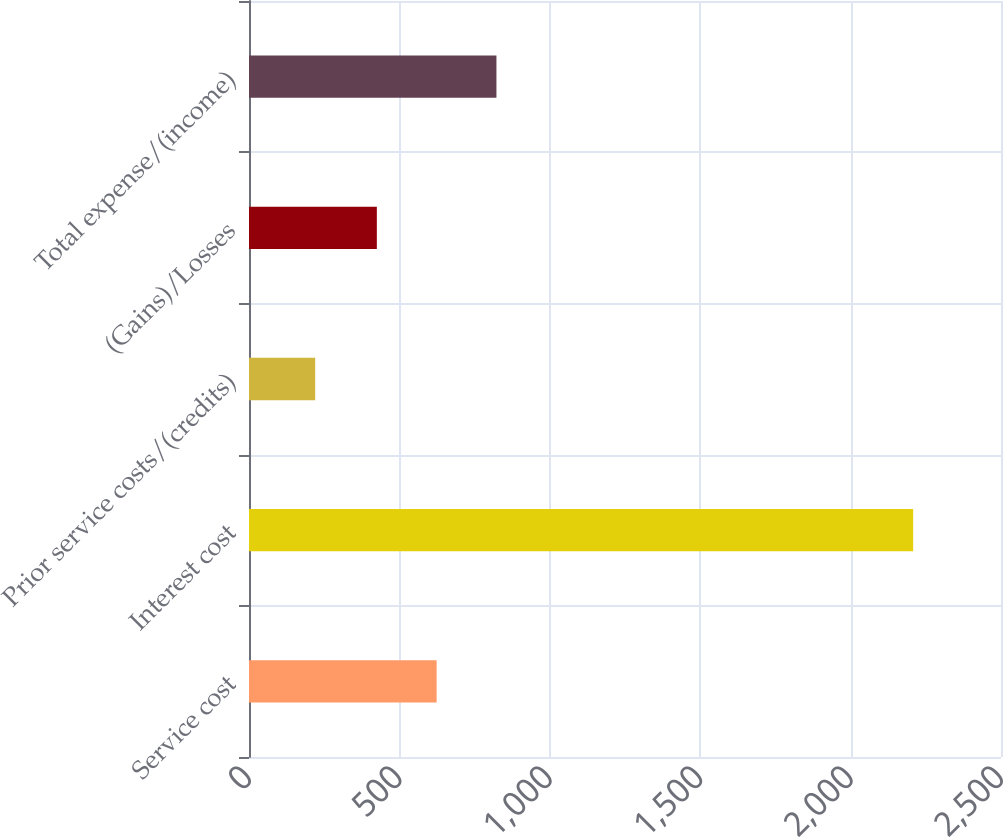Convert chart to OTSL. <chart><loc_0><loc_0><loc_500><loc_500><bar_chart><fcel>Service cost<fcel>Interest cost<fcel>Prior service costs/(credits)<fcel>(Gains)/Losses<fcel>Total expense/(income)<nl><fcel>623.8<fcel>2208<fcel>220<fcel>425<fcel>822.6<nl></chart> 